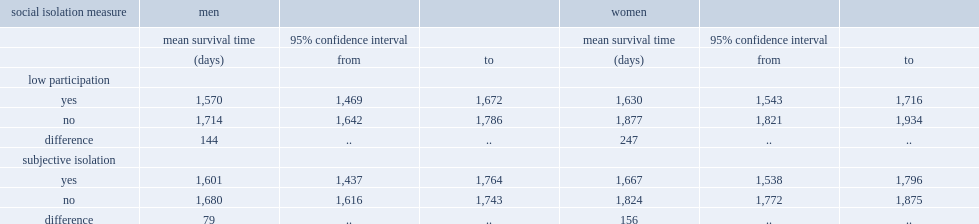Who had shorter survival times,low participating men and women or those frequently in community-related activities? Low participation. For women,who had shorter survival time,low participators or high participators? Low participation. 